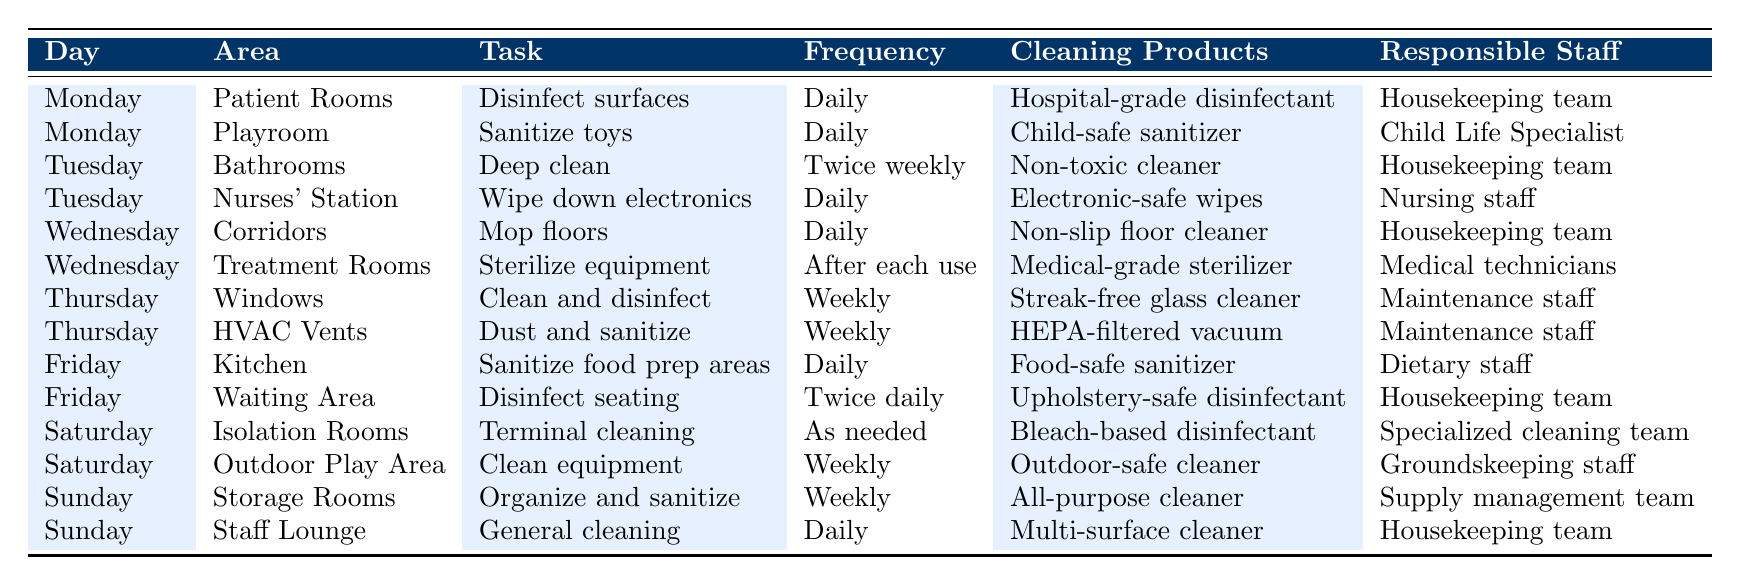What tasks are assigned for cleaning on Mondays? The table lists two tasks for Mondays: disinfecting surfaces in Patient Rooms and sanitizing toys in the Playroom.
Answer: Disinfect surfaces; Sanitize toys How often is the treatment room equipment sterilized? The table specifies that equipment in the Treatment Rooms is sterilized after each use.
Answer: After each use Which areas are cleaned daily? The table indicates the following areas are cleaned daily: Patient Rooms, Playroom, Nurses' Station, Corridors, Kitchen, Waiting Area, and Staff Lounge.
Answer: Patient Rooms, Playroom, Nurses' Station, Corridors, Kitchen, Waiting Area, Staff Lounge True or False: The outdoor play area is cleaned daily. According to the table, the Outdoor Play Area is cleaned weekly, not daily.
Answer: False What cleaning products are used for the bathrooms? The cleaning product specified for the bathrooms is a non-toxic cleaner.
Answer: Non-toxic cleaner How many areas are served by the housekeeping team throughout the week? The housekeeping team is responsible for Patient Rooms, Bathrooms, Corridors, Waiting Area, and Staff Lounge, totaling five areas.
Answer: Five areas Which staff is responsible for sanitizing toys in the Playroom? The Child Life Specialist is responsible for sanitizing toys in the Playroom as noted in the table.
Answer: Child Life Specialist What are the different frequencies of cleaning tasks listed in the table? The cleaning frequencies include daily, twice weekly, weekly, after each use, and as needed.
Answer: Daily, twice weekly, weekly, after each use, as needed On which day is the HVAC Vents dusted and sanitized? According to the table, HVAC Vents are dusted and sanitized on Thursdays.
Answer: Thursday Which areas require terminal cleaning and how often? Terminal cleaning is required in Isolation Rooms as needed, meaning it does not follow a specific frequency but instead is based on specific circumstances.
Answer: As needed in Isolation Rooms How do the cleaning frequencies compare between indoor and outdoor areas? Indoor areas like Patient Rooms and Bathrooms are cleaned daily or weekly, while outdoor areas like the Outdoor Play Area are typically cleaned weekly. The indoor areas have higher cleaning frequencies.
Answer: Indoor areas are cleaned more frequently than outdoor areas 